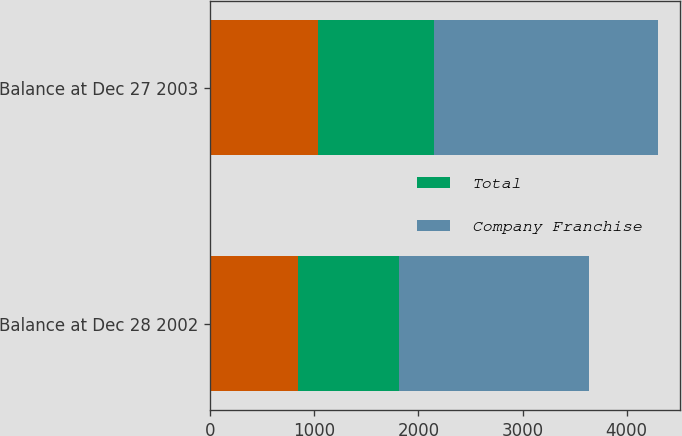<chart> <loc_0><loc_0><loc_500><loc_500><stacked_bar_chart><ecel><fcel>Balance at Dec 28 2002<fcel>Balance at Dec 27 2003<nl><fcel>nan<fcel>844<fcel>1032<nl><fcel>Total<fcel>973<fcel>1116<nl><fcel>Company Franchise<fcel>1817<fcel>2148<nl></chart> 